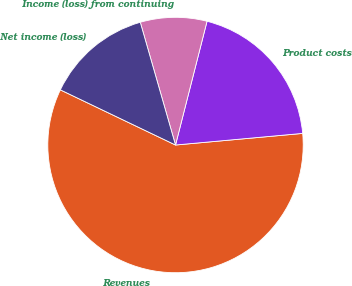<chart> <loc_0><loc_0><loc_500><loc_500><pie_chart><fcel>Revenues<fcel>Product costs<fcel>Income (loss) from continuing<fcel>Net income (loss)<nl><fcel>58.56%<fcel>19.58%<fcel>8.42%<fcel>13.44%<nl></chart> 